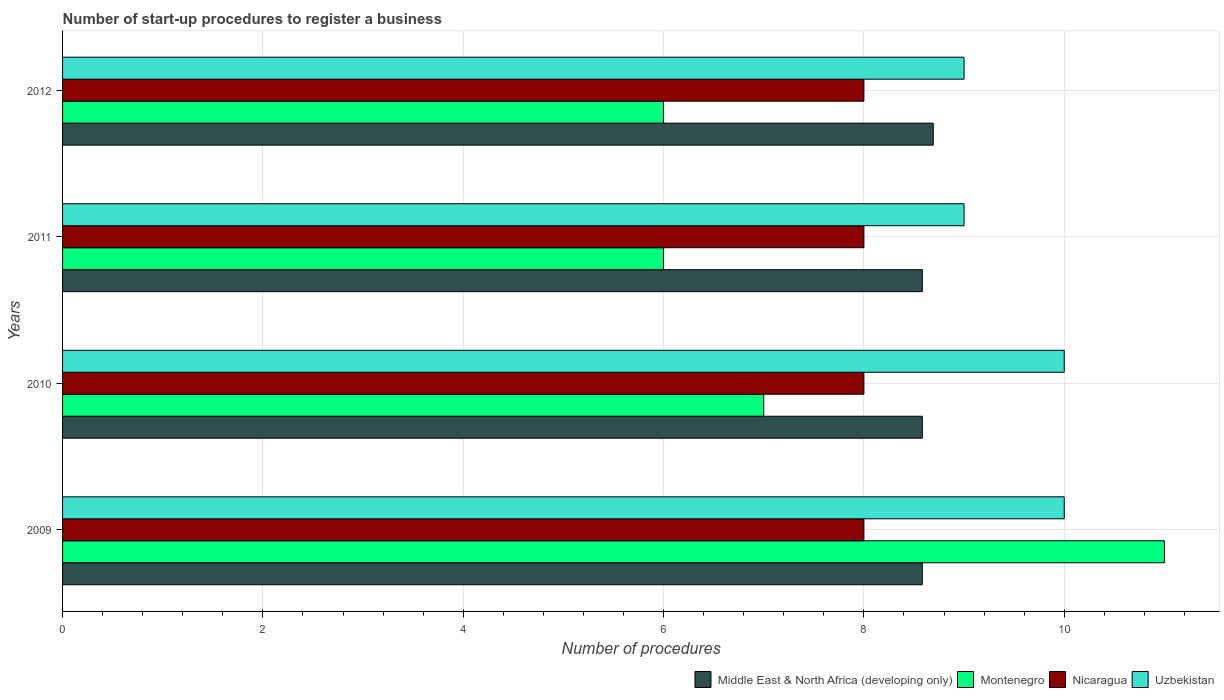How many groups of bars are there?
Provide a succinct answer. 4. Are the number of bars on each tick of the Y-axis equal?
Give a very brief answer. Yes. In how many cases, is the number of bars for a given year not equal to the number of legend labels?
Give a very brief answer. 0. What is the number of procedures required to register a business in Uzbekistan in 2009?
Offer a very short reply. 10. Across all years, what is the maximum number of procedures required to register a business in Middle East & North Africa (developing only)?
Provide a succinct answer. 8.69. In which year was the number of procedures required to register a business in Middle East & North Africa (developing only) minimum?
Give a very brief answer. 2009. What is the total number of procedures required to register a business in Middle East & North Africa (developing only) in the graph?
Keep it short and to the point. 34.44. What is the difference between the number of procedures required to register a business in Nicaragua in 2011 and that in 2012?
Offer a terse response. 0. What is the average number of procedures required to register a business in Montenegro per year?
Give a very brief answer. 7.5. In the year 2012, what is the difference between the number of procedures required to register a business in Montenegro and number of procedures required to register a business in Uzbekistan?
Your answer should be very brief. -3. In how many years, is the number of procedures required to register a business in Nicaragua greater than 4.4 ?
Ensure brevity in your answer.  4. What is the ratio of the number of procedures required to register a business in Montenegro in 2010 to that in 2012?
Provide a short and direct response. 1.17. Is the difference between the number of procedures required to register a business in Montenegro in 2009 and 2010 greater than the difference between the number of procedures required to register a business in Uzbekistan in 2009 and 2010?
Your answer should be very brief. Yes. What is the difference between the highest and the second highest number of procedures required to register a business in Montenegro?
Your response must be concise. 4. What is the difference between the highest and the lowest number of procedures required to register a business in Middle East & North Africa (developing only)?
Provide a short and direct response. 0.11. In how many years, is the number of procedures required to register a business in Uzbekistan greater than the average number of procedures required to register a business in Uzbekistan taken over all years?
Provide a succinct answer. 2. Is the sum of the number of procedures required to register a business in Montenegro in 2010 and 2012 greater than the maximum number of procedures required to register a business in Middle East & North Africa (developing only) across all years?
Your response must be concise. Yes. What does the 2nd bar from the top in 2011 represents?
Give a very brief answer. Nicaragua. What does the 4th bar from the bottom in 2012 represents?
Keep it short and to the point. Uzbekistan. How many bars are there?
Ensure brevity in your answer.  16. How many years are there in the graph?
Your answer should be very brief. 4. Are the values on the major ticks of X-axis written in scientific E-notation?
Keep it short and to the point. No. Does the graph contain grids?
Your answer should be very brief. Yes. Where does the legend appear in the graph?
Ensure brevity in your answer.  Bottom right. How many legend labels are there?
Provide a short and direct response. 4. What is the title of the graph?
Keep it short and to the point. Number of start-up procedures to register a business. What is the label or title of the X-axis?
Make the answer very short. Number of procedures. What is the Number of procedures in Middle East & North Africa (developing only) in 2009?
Your answer should be compact. 8.58. What is the Number of procedures of Montenegro in 2009?
Give a very brief answer. 11. What is the Number of procedures of Nicaragua in 2009?
Ensure brevity in your answer.  8. What is the Number of procedures in Uzbekistan in 2009?
Offer a terse response. 10. What is the Number of procedures of Middle East & North Africa (developing only) in 2010?
Provide a short and direct response. 8.58. What is the Number of procedures in Montenegro in 2010?
Provide a short and direct response. 7. What is the Number of procedures of Nicaragua in 2010?
Your answer should be very brief. 8. What is the Number of procedures of Middle East & North Africa (developing only) in 2011?
Provide a succinct answer. 8.58. What is the Number of procedures of Montenegro in 2011?
Provide a succinct answer. 6. What is the Number of procedures of Middle East & North Africa (developing only) in 2012?
Make the answer very short. 8.69. What is the Number of procedures in Montenegro in 2012?
Provide a succinct answer. 6. Across all years, what is the maximum Number of procedures of Middle East & North Africa (developing only)?
Provide a succinct answer. 8.69. Across all years, what is the maximum Number of procedures of Montenegro?
Provide a succinct answer. 11. Across all years, what is the maximum Number of procedures of Nicaragua?
Provide a succinct answer. 8. Across all years, what is the minimum Number of procedures of Middle East & North Africa (developing only)?
Provide a succinct answer. 8.58. Across all years, what is the minimum Number of procedures of Montenegro?
Your answer should be very brief. 6. Across all years, what is the minimum Number of procedures of Nicaragua?
Make the answer very short. 8. Across all years, what is the minimum Number of procedures in Uzbekistan?
Keep it short and to the point. 9. What is the total Number of procedures in Middle East & North Africa (developing only) in the graph?
Keep it short and to the point. 34.44. What is the difference between the Number of procedures in Nicaragua in 2009 and that in 2010?
Ensure brevity in your answer.  0. What is the difference between the Number of procedures of Uzbekistan in 2009 and that in 2010?
Provide a short and direct response. 0. What is the difference between the Number of procedures in Middle East & North Africa (developing only) in 2009 and that in 2011?
Your response must be concise. 0. What is the difference between the Number of procedures in Nicaragua in 2009 and that in 2011?
Provide a short and direct response. 0. What is the difference between the Number of procedures of Middle East & North Africa (developing only) in 2009 and that in 2012?
Your answer should be very brief. -0.11. What is the difference between the Number of procedures in Montenegro in 2009 and that in 2012?
Your response must be concise. 5. What is the difference between the Number of procedures of Nicaragua in 2009 and that in 2012?
Offer a terse response. 0. What is the difference between the Number of procedures of Middle East & North Africa (developing only) in 2010 and that in 2011?
Keep it short and to the point. 0. What is the difference between the Number of procedures in Montenegro in 2010 and that in 2011?
Provide a short and direct response. 1. What is the difference between the Number of procedures of Nicaragua in 2010 and that in 2011?
Give a very brief answer. 0. What is the difference between the Number of procedures in Middle East & North Africa (developing only) in 2010 and that in 2012?
Provide a succinct answer. -0.11. What is the difference between the Number of procedures of Montenegro in 2010 and that in 2012?
Ensure brevity in your answer.  1. What is the difference between the Number of procedures in Nicaragua in 2010 and that in 2012?
Your response must be concise. 0. What is the difference between the Number of procedures of Uzbekistan in 2010 and that in 2012?
Make the answer very short. 1. What is the difference between the Number of procedures in Middle East & North Africa (developing only) in 2011 and that in 2012?
Offer a terse response. -0.11. What is the difference between the Number of procedures in Nicaragua in 2011 and that in 2012?
Your response must be concise. 0. What is the difference between the Number of procedures of Middle East & North Africa (developing only) in 2009 and the Number of procedures of Montenegro in 2010?
Your answer should be very brief. 1.58. What is the difference between the Number of procedures in Middle East & North Africa (developing only) in 2009 and the Number of procedures in Nicaragua in 2010?
Ensure brevity in your answer.  0.58. What is the difference between the Number of procedures of Middle East & North Africa (developing only) in 2009 and the Number of procedures of Uzbekistan in 2010?
Ensure brevity in your answer.  -1.42. What is the difference between the Number of procedures of Middle East & North Africa (developing only) in 2009 and the Number of procedures of Montenegro in 2011?
Provide a succinct answer. 2.58. What is the difference between the Number of procedures of Middle East & North Africa (developing only) in 2009 and the Number of procedures of Nicaragua in 2011?
Keep it short and to the point. 0.58. What is the difference between the Number of procedures in Middle East & North Africa (developing only) in 2009 and the Number of procedures in Uzbekistan in 2011?
Your answer should be very brief. -0.42. What is the difference between the Number of procedures of Middle East & North Africa (developing only) in 2009 and the Number of procedures of Montenegro in 2012?
Your response must be concise. 2.58. What is the difference between the Number of procedures of Middle East & North Africa (developing only) in 2009 and the Number of procedures of Nicaragua in 2012?
Your answer should be very brief. 0.58. What is the difference between the Number of procedures in Middle East & North Africa (developing only) in 2009 and the Number of procedures in Uzbekistan in 2012?
Your answer should be very brief. -0.42. What is the difference between the Number of procedures of Montenegro in 2009 and the Number of procedures of Nicaragua in 2012?
Your response must be concise. 3. What is the difference between the Number of procedures of Middle East & North Africa (developing only) in 2010 and the Number of procedures of Montenegro in 2011?
Offer a very short reply. 2.58. What is the difference between the Number of procedures in Middle East & North Africa (developing only) in 2010 and the Number of procedures in Nicaragua in 2011?
Offer a very short reply. 0.58. What is the difference between the Number of procedures in Middle East & North Africa (developing only) in 2010 and the Number of procedures in Uzbekistan in 2011?
Offer a very short reply. -0.42. What is the difference between the Number of procedures in Montenegro in 2010 and the Number of procedures in Nicaragua in 2011?
Keep it short and to the point. -1. What is the difference between the Number of procedures of Nicaragua in 2010 and the Number of procedures of Uzbekistan in 2011?
Your answer should be very brief. -1. What is the difference between the Number of procedures of Middle East & North Africa (developing only) in 2010 and the Number of procedures of Montenegro in 2012?
Ensure brevity in your answer.  2.58. What is the difference between the Number of procedures of Middle East & North Africa (developing only) in 2010 and the Number of procedures of Nicaragua in 2012?
Your answer should be compact. 0.58. What is the difference between the Number of procedures in Middle East & North Africa (developing only) in 2010 and the Number of procedures in Uzbekistan in 2012?
Give a very brief answer. -0.42. What is the difference between the Number of procedures in Nicaragua in 2010 and the Number of procedures in Uzbekistan in 2012?
Your answer should be compact. -1. What is the difference between the Number of procedures of Middle East & North Africa (developing only) in 2011 and the Number of procedures of Montenegro in 2012?
Offer a very short reply. 2.58. What is the difference between the Number of procedures of Middle East & North Africa (developing only) in 2011 and the Number of procedures of Nicaragua in 2012?
Make the answer very short. 0.58. What is the difference between the Number of procedures of Middle East & North Africa (developing only) in 2011 and the Number of procedures of Uzbekistan in 2012?
Make the answer very short. -0.42. What is the difference between the Number of procedures of Montenegro in 2011 and the Number of procedures of Uzbekistan in 2012?
Offer a terse response. -3. What is the average Number of procedures of Middle East & North Africa (developing only) per year?
Ensure brevity in your answer.  8.61. What is the average Number of procedures in Montenegro per year?
Your response must be concise. 7.5. What is the average Number of procedures in Nicaragua per year?
Your answer should be compact. 8. In the year 2009, what is the difference between the Number of procedures in Middle East & North Africa (developing only) and Number of procedures in Montenegro?
Give a very brief answer. -2.42. In the year 2009, what is the difference between the Number of procedures of Middle East & North Africa (developing only) and Number of procedures of Nicaragua?
Your answer should be very brief. 0.58. In the year 2009, what is the difference between the Number of procedures of Middle East & North Africa (developing only) and Number of procedures of Uzbekistan?
Offer a very short reply. -1.42. In the year 2009, what is the difference between the Number of procedures in Nicaragua and Number of procedures in Uzbekistan?
Your answer should be very brief. -2. In the year 2010, what is the difference between the Number of procedures of Middle East & North Africa (developing only) and Number of procedures of Montenegro?
Ensure brevity in your answer.  1.58. In the year 2010, what is the difference between the Number of procedures of Middle East & North Africa (developing only) and Number of procedures of Nicaragua?
Give a very brief answer. 0.58. In the year 2010, what is the difference between the Number of procedures in Middle East & North Africa (developing only) and Number of procedures in Uzbekistan?
Ensure brevity in your answer.  -1.42. In the year 2010, what is the difference between the Number of procedures in Montenegro and Number of procedures in Nicaragua?
Provide a succinct answer. -1. In the year 2010, what is the difference between the Number of procedures in Montenegro and Number of procedures in Uzbekistan?
Keep it short and to the point. -3. In the year 2011, what is the difference between the Number of procedures in Middle East & North Africa (developing only) and Number of procedures in Montenegro?
Keep it short and to the point. 2.58. In the year 2011, what is the difference between the Number of procedures of Middle East & North Africa (developing only) and Number of procedures of Nicaragua?
Offer a very short reply. 0.58. In the year 2011, what is the difference between the Number of procedures of Middle East & North Africa (developing only) and Number of procedures of Uzbekistan?
Keep it short and to the point. -0.42. In the year 2011, what is the difference between the Number of procedures of Montenegro and Number of procedures of Uzbekistan?
Give a very brief answer. -3. In the year 2012, what is the difference between the Number of procedures of Middle East & North Africa (developing only) and Number of procedures of Montenegro?
Provide a succinct answer. 2.69. In the year 2012, what is the difference between the Number of procedures of Middle East & North Africa (developing only) and Number of procedures of Nicaragua?
Keep it short and to the point. 0.69. In the year 2012, what is the difference between the Number of procedures in Middle East & North Africa (developing only) and Number of procedures in Uzbekistan?
Keep it short and to the point. -0.31. In the year 2012, what is the difference between the Number of procedures in Montenegro and Number of procedures in Nicaragua?
Provide a succinct answer. -2. What is the ratio of the Number of procedures in Montenegro in 2009 to that in 2010?
Provide a short and direct response. 1.57. What is the ratio of the Number of procedures of Nicaragua in 2009 to that in 2010?
Your answer should be very brief. 1. What is the ratio of the Number of procedures of Uzbekistan in 2009 to that in 2010?
Make the answer very short. 1. What is the ratio of the Number of procedures of Montenegro in 2009 to that in 2011?
Your answer should be very brief. 1.83. What is the ratio of the Number of procedures in Middle East & North Africa (developing only) in 2009 to that in 2012?
Make the answer very short. 0.99. What is the ratio of the Number of procedures in Montenegro in 2009 to that in 2012?
Give a very brief answer. 1.83. What is the ratio of the Number of procedures of Nicaragua in 2009 to that in 2012?
Provide a succinct answer. 1. What is the ratio of the Number of procedures in Uzbekistan in 2009 to that in 2012?
Your response must be concise. 1.11. What is the ratio of the Number of procedures in Montenegro in 2010 to that in 2011?
Ensure brevity in your answer.  1.17. What is the ratio of the Number of procedures in Nicaragua in 2010 to that in 2011?
Your answer should be compact. 1. What is the ratio of the Number of procedures in Uzbekistan in 2010 to that in 2011?
Give a very brief answer. 1.11. What is the ratio of the Number of procedures of Middle East & North Africa (developing only) in 2010 to that in 2012?
Give a very brief answer. 0.99. What is the ratio of the Number of procedures of Middle East & North Africa (developing only) in 2011 to that in 2012?
Give a very brief answer. 0.99. What is the ratio of the Number of procedures of Montenegro in 2011 to that in 2012?
Provide a succinct answer. 1. What is the ratio of the Number of procedures of Nicaragua in 2011 to that in 2012?
Your response must be concise. 1. What is the ratio of the Number of procedures in Uzbekistan in 2011 to that in 2012?
Make the answer very short. 1. What is the difference between the highest and the second highest Number of procedures of Middle East & North Africa (developing only)?
Offer a terse response. 0.11. What is the difference between the highest and the lowest Number of procedures of Middle East & North Africa (developing only)?
Your response must be concise. 0.11. What is the difference between the highest and the lowest Number of procedures of Nicaragua?
Offer a very short reply. 0. What is the difference between the highest and the lowest Number of procedures of Uzbekistan?
Your answer should be very brief. 1. 